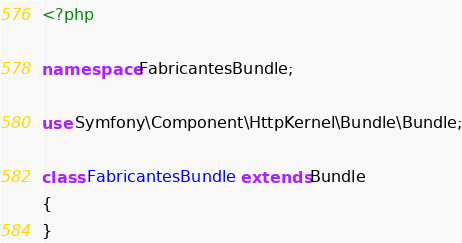Convert code to text. <code><loc_0><loc_0><loc_500><loc_500><_PHP_><?php

namespace FabricantesBundle;

use Symfony\Component\HttpKernel\Bundle\Bundle;

class FabricantesBundle extends Bundle
{
}
</code> 